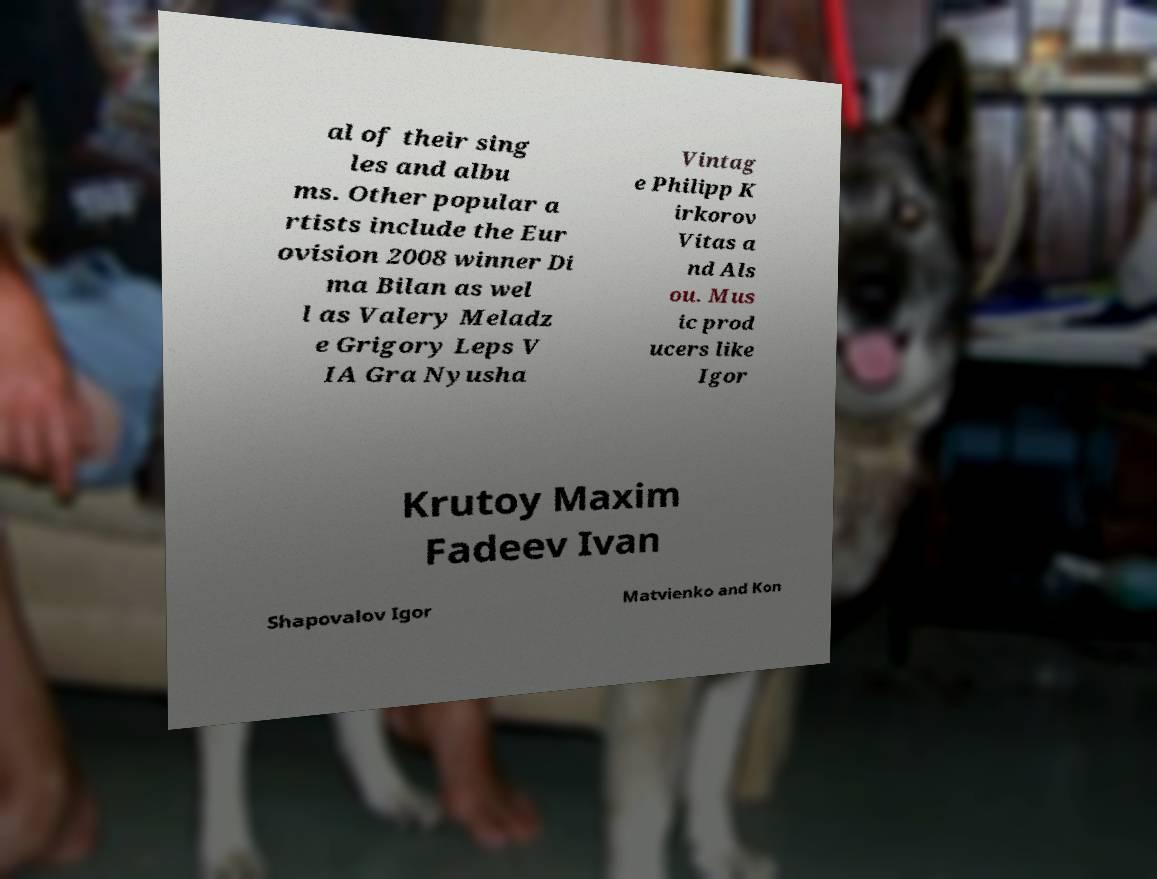Please read and relay the text visible in this image. What does it say? al of their sing les and albu ms. Other popular a rtists include the Eur ovision 2008 winner Di ma Bilan as wel l as Valery Meladz e Grigory Leps V IA Gra Nyusha Vintag e Philipp K irkorov Vitas a nd Als ou. Mus ic prod ucers like Igor Krutoy Maxim Fadeev Ivan Shapovalov Igor Matvienko and Kon 